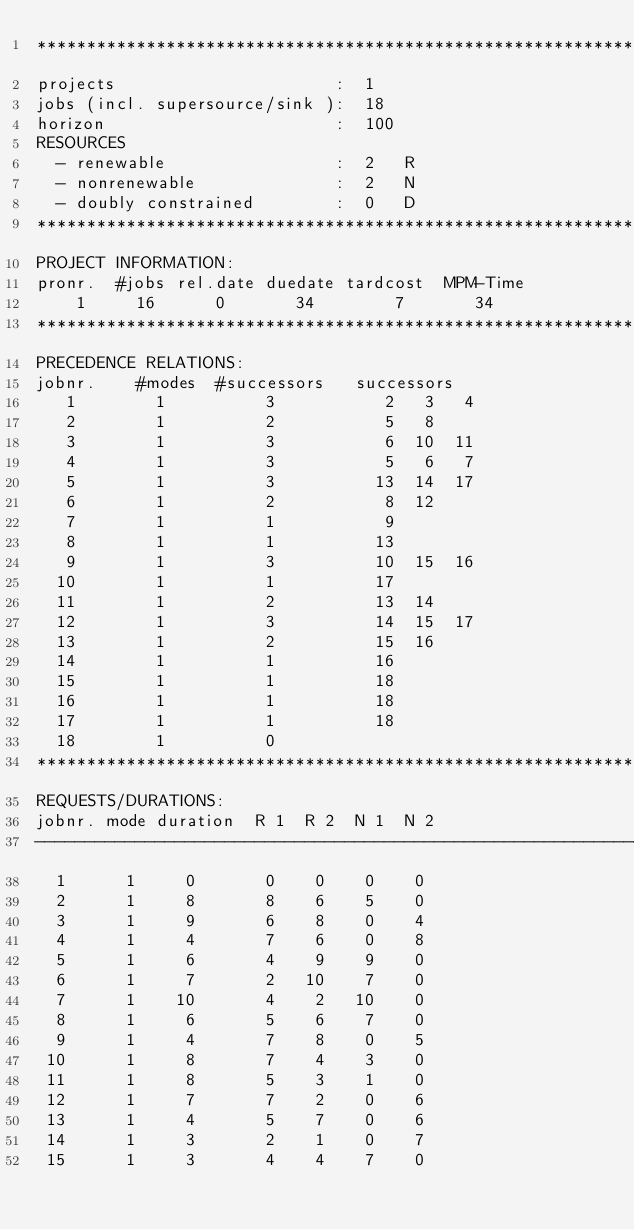Convert code to text. <code><loc_0><loc_0><loc_500><loc_500><_ObjectiveC_>************************************************************************
projects                      :  1
jobs (incl. supersource/sink ):  18
horizon                       :  100
RESOURCES
  - renewable                 :  2   R
  - nonrenewable              :  2   N
  - doubly constrained        :  0   D
************************************************************************
PROJECT INFORMATION:
pronr.  #jobs rel.date duedate tardcost  MPM-Time
    1     16      0       34        7       34
************************************************************************
PRECEDENCE RELATIONS:
jobnr.    #modes  #successors   successors
   1        1          3           2   3   4
   2        1          2           5   8
   3        1          3           6  10  11
   4        1          3           5   6   7
   5        1          3          13  14  17
   6        1          2           8  12
   7        1          1           9
   8        1          1          13
   9        1          3          10  15  16
  10        1          1          17
  11        1          2          13  14
  12        1          3          14  15  17
  13        1          2          15  16
  14        1          1          16
  15        1          1          18
  16        1          1          18
  17        1          1          18
  18        1          0        
************************************************************************
REQUESTS/DURATIONS:
jobnr. mode duration  R 1  R 2  N 1  N 2
------------------------------------------------------------------------
  1      1     0       0    0    0    0
  2      1     8       8    6    5    0
  3      1     9       6    8    0    4
  4      1     4       7    6    0    8
  5      1     6       4    9    9    0
  6      1     7       2   10    7    0
  7      1    10       4    2   10    0
  8      1     6       5    6    7    0
  9      1     4       7    8    0    5
 10      1     8       7    4    3    0
 11      1     8       5    3    1    0
 12      1     7       7    2    0    6
 13      1     4       5    7    0    6
 14      1     3       2    1    0    7
 15      1     3       4    4    7    0</code> 